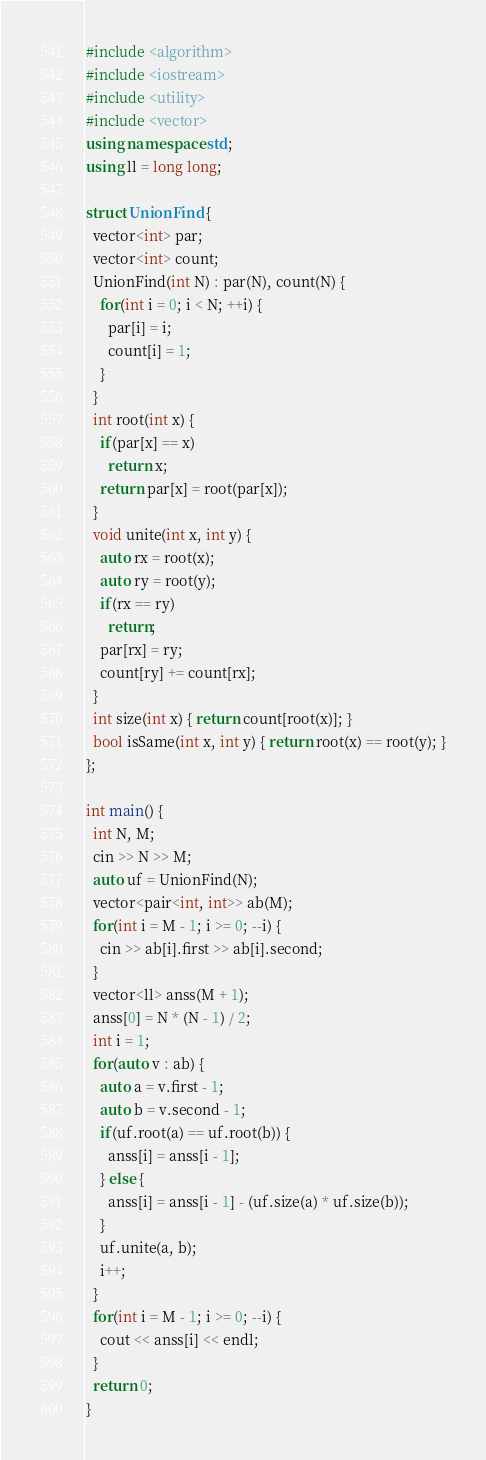Convert code to text. <code><loc_0><loc_0><loc_500><loc_500><_C++_>#include <algorithm>
#include <iostream>
#include <utility>
#include <vector>
using namespace std;
using ll = long long;

struct UnionFind {
  vector<int> par;
  vector<int> count;
  UnionFind(int N) : par(N), count(N) {
    for(int i = 0; i < N; ++i) {
      par[i] = i;
      count[i] = 1;
    }
  }
  int root(int x) {
    if(par[x] == x)
      return x;
    return par[x] = root(par[x]);
  }
  void unite(int x, int y) {
    auto rx = root(x);
    auto ry = root(y);
    if(rx == ry)
      return;
    par[rx] = ry;
    count[ry] += count[rx];
  }
  int size(int x) { return count[root(x)]; }
  bool isSame(int x, int y) { return root(x) == root(y); }
};

int main() {
  int N, M;
  cin >> N >> M;
  auto uf = UnionFind(N);
  vector<pair<int, int>> ab(M);
  for(int i = M - 1; i >= 0; --i) {
    cin >> ab[i].first >> ab[i].second;
  }
  vector<ll> anss(M + 1);
  anss[0] = N * (N - 1) / 2;
  int i = 1;
  for(auto v : ab) {
    auto a = v.first - 1;
    auto b = v.second - 1;
    if(uf.root(a) == uf.root(b)) {
      anss[i] = anss[i - 1];
    } else {
      anss[i] = anss[i - 1] - (uf.size(a) * uf.size(b));
    }
    uf.unite(a, b);
    i++;
  }
  for(int i = M - 1; i >= 0; --i) {
    cout << anss[i] << endl;
  }
  return 0;
}</code> 